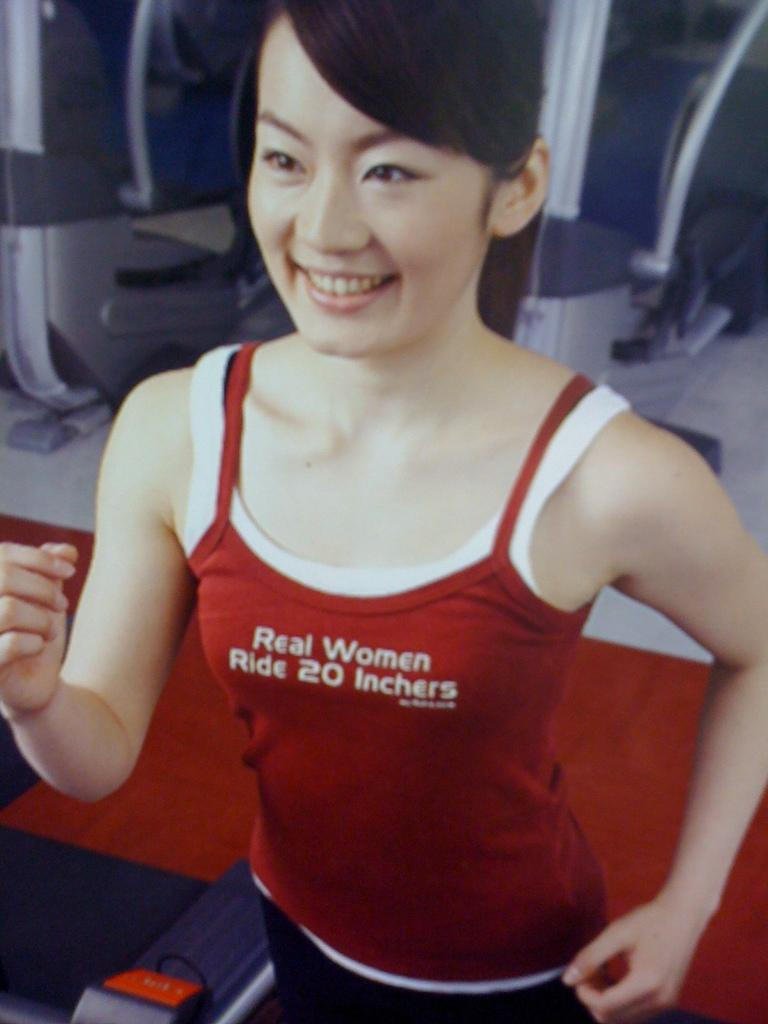<image>
Offer a succinct explanation of the picture presented. a lady that has the words real women on her shirt 